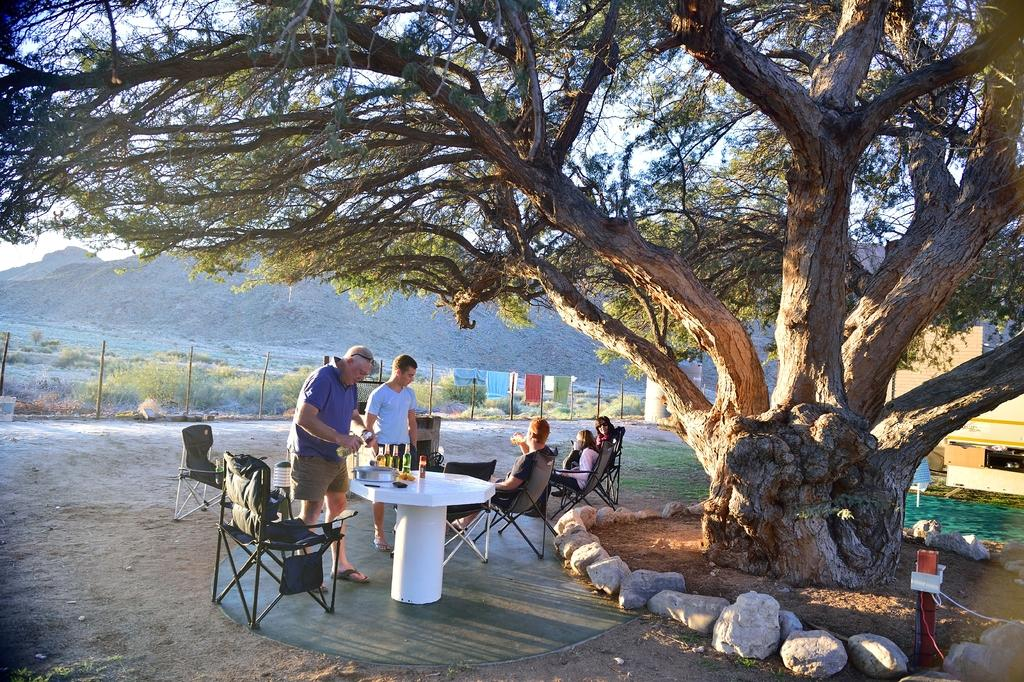What are the people in the image doing? The people in the image are sitting on chairs. What is the man in the image doing? The man is taking beer bottles. What can be seen on the right side of the image? There is a big tree on the right side of the image. What is located behind the tree in the image? There is a building behind the tree in the image. Can you see a receipt for the beer bottles in the image? There is no receipt visible in the image. Is there a goat present in the image? There is no goat present in the image. 